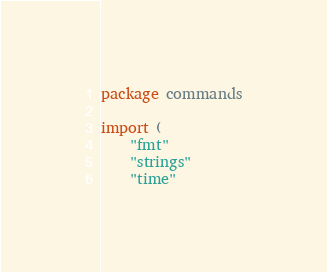Convert code to text. <code><loc_0><loc_0><loc_500><loc_500><_Go_>package commands

import (
	"fmt"
	"strings"
	"time"
</code> 